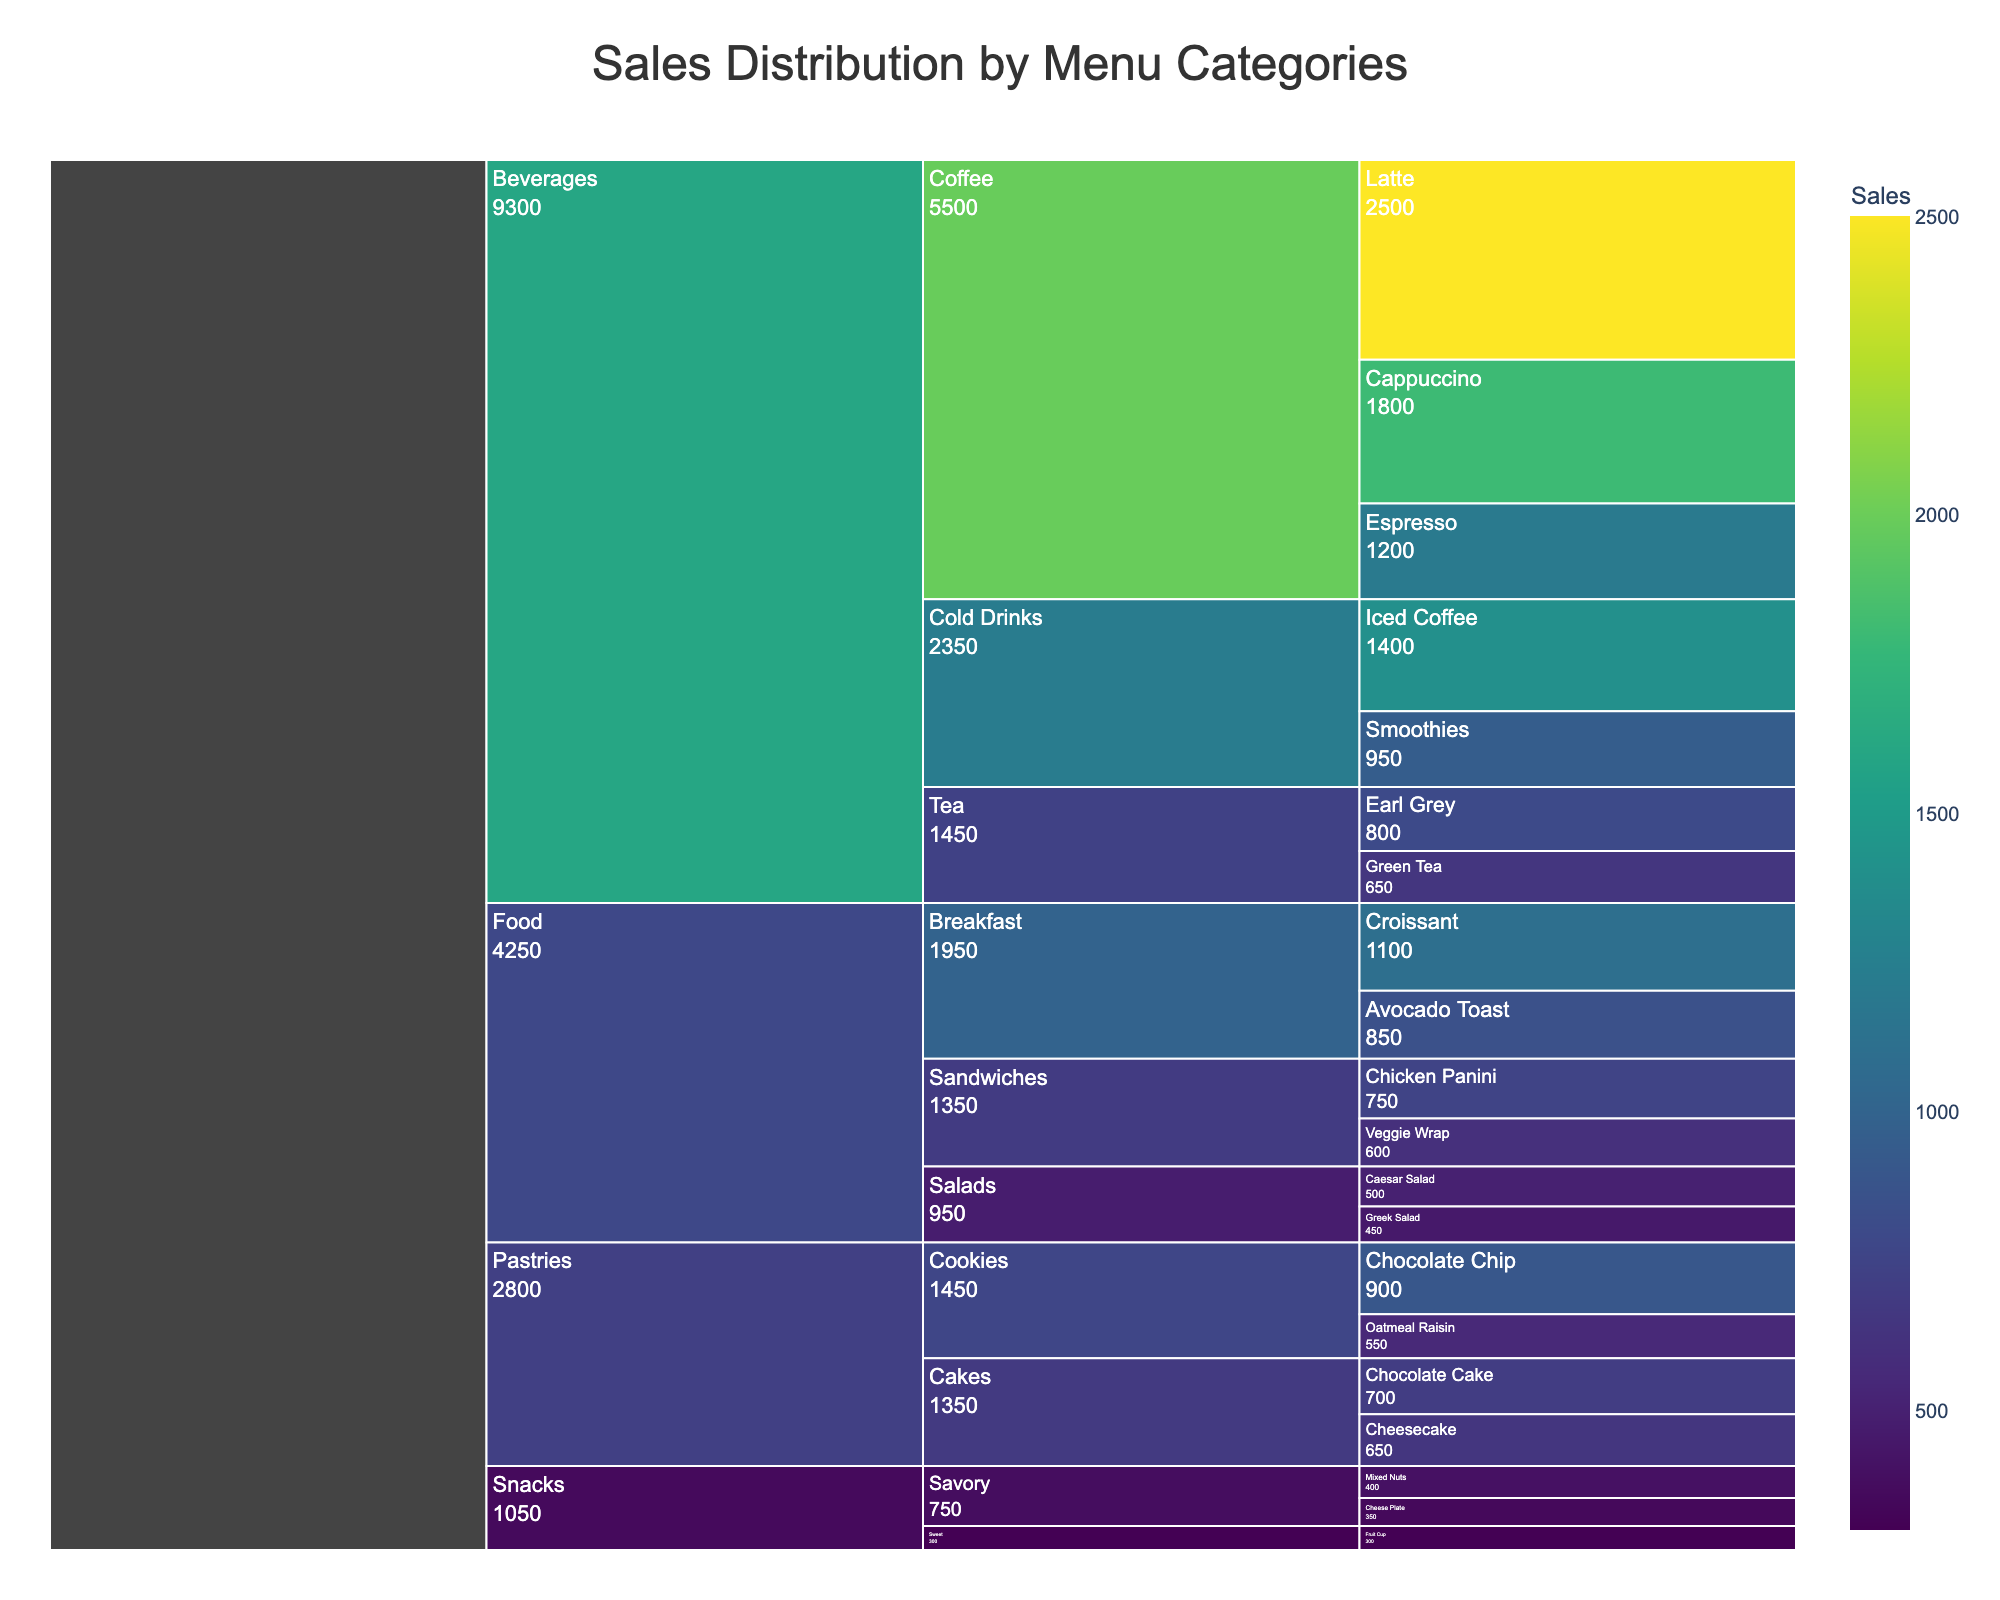What is the title of the chart? The title is usually written at the top of the chart. In this case, it indicates the topic or focus of the visualization directly.
Answer: Sales Distribution by Menu Categories Which menu category has the highest total sales? Look at the largest colored sections within the Icicle Chart for each category. The category with the widest section represents the one with the highest sales.
Answer: Beverages What is the sum of sales for all the Coffee subcategory items? The Coffee subcategory has sales from Espresso, Latte, and Cappuccino. Adding these gives us 1200 + 2500 + 1800.
Answer: 5500 Which subcategory in the Food category has higher sales, Breakfast or Sandwiches? Compare the sizes of the "Breakfast" and "Sandwiches" subcategories within the "Food" category. The larger section represents the higher sales value.
Answer: Breakfast What percentage of total sales does the Croissant item represent? First, determine the total sales from all items. Then, divide Croissant sales by the total sales and convert to a percentage: \( \frac{1100}{20500} \times 100 \).
Answer: 5.37% Does the category with the lowest total sales contain any items above 500 in sales? Check the smallest category as identified by the Icicle Chart and then see if any of its subcategories or items have sales above 500.
Answer: No Is Latte the item with the highest sales in the Coffee subcategory? Look at the Coffee subcategory and compare the sales figures for Espresso, Latte, and Cappuccino. The chart visualizes the largest section in this subcategory.
Answer: Yes What is the difference in sales between Iced Coffee and Smoothies? Subtract the sales of Smoothies from the sales of Iced Coffee: 1400 - 950.
Answer: 450 In which subcategory under Pastries does Chocolate Chip Cookies fall? Locate the item "Chocolate Chip Cookies" in the Icicle Chart and note the subcategory to which it belongs.
Answer: Cookies 